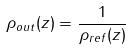<formula> <loc_0><loc_0><loc_500><loc_500>\rho _ { o u t } ( z ) = \frac { 1 } { \rho _ { r e f } ( z ) }</formula> 